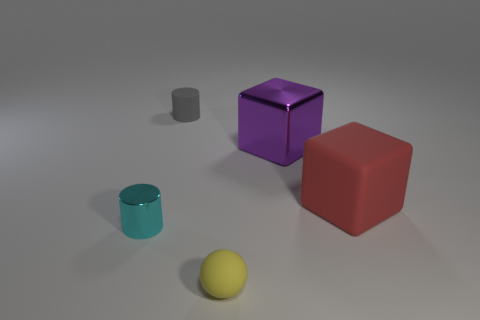Add 1 small objects. How many objects exist? 6 Subtract all spheres. How many objects are left? 4 Subtract all brown shiny things. Subtract all big blocks. How many objects are left? 3 Add 4 large purple things. How many large purple things are left? 5 Add 3 big purple shiny cubes. How many big purple shiny cubes exist? 4 Subtract 0 green blocks. How many objects are left? 5 